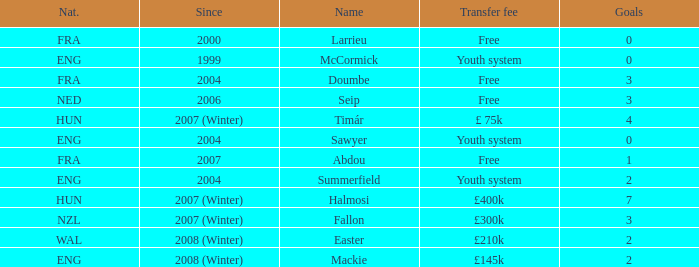On average, how many goals does sawyer have? 0.0. 